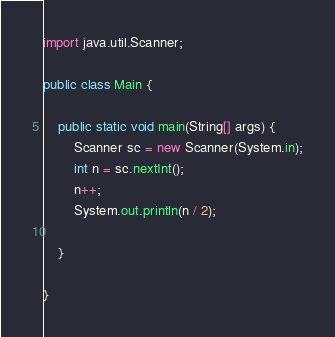Convert code to text. <code><loc_0><loc_0><loc_500><loc_500><_Java_>
import java.util.Scanner;

public class Main {

	public static void main(String[] args) {
		Scanner sc = new Scanner(System.in);
		int n = sc.nextInt();
		n++;
		System.out.println(n / 2);

	}

}
</code> 